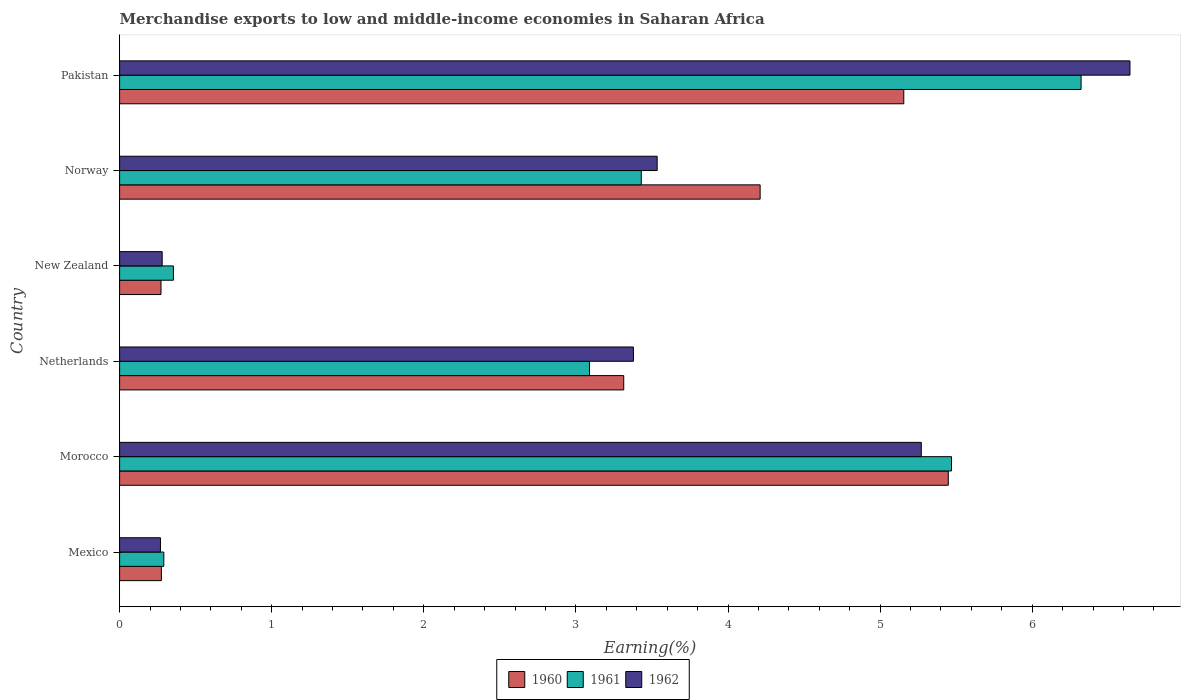How many different coloured bars are there?
Offer a terse response. 3. How many groups of bars are there?
Offer a terse response. 6. Are the number of bars per tick equal to the number of legend labels?
Ensure brevity in your answer.  Yes. Are the number of bars on each tick of the Y-axis equal?
Make the answer very short. Yes. How many bars are there on the 6th tick from the top?
Offer a very short reply. 3. What is the label of the 5th group of bars from the top?
Ensure brevity in your answer.  Morocco. What is the percentage of amount earned from merchandise exports in 1961 in Norway?
Provide a succinct answer. 3.43. Across all countries, what is the maximum percentage of amount earned from merchandise exports in 1962?
Provide a short and direct response. 6.64. Across all countries, what is the minimum percentage of amount earned from merchandise exports in 1961?
Your answer should be very brief. 0.29. In which country was the percentage of amount earned from merchandise exports in 1960 maximum?
Your response must be concise. Morocco. In which country was the percentage of amount earned from merchandise exports in 1961 minimum?
Keep it short and to the point. Mexico. What is the total percentage of amount earned from merchandise exports in 1962 in the graph?
Offer a terse response. 19.37. What is the difference between the percentage of amount earned from merchandise exports in 1962 in Mexico and that in Netherlands?
Your answer should be compact. -3.11. What is the difference between the percentage of amount earned from merchandise exports in 1961 in Morocco and the percentage of amount earned from merchandise exports in 1960 in Mexico?
Keep it short and to the point. 5.19. What is the average percentage of amount earned from merchandise exports in 1960 per country?
Give a very brief answer. 3.11. What is the difference between the percentage of amount earned from merchandise exports in 1962 and percentage of amount earned from merchandise exports in 1961 in Norway?
Offer a very short reply. 0.1. What is the ratio of the percentage of amount earned from merchandise exports in 1961 in Netherlands to that in Pakistan?
Your answer should be compact. 0.49. What is the difference between the highest and the second highest percentage of amount earned from merchandise exports in 1961?
Your answer should be compact. 0.85. What is the difference between the highest and the lowest percentage of amount earned from merchandise exports in 1962?
Keep it short and to the point. 6.37. In how many countries, is the percentage of amount earned from merchandise exports in 1962 greater than the average percentage of amount earned from merchandise exports in 1962 taken over all countries?
Give a very brief answer. 4. Is the sum of the percentage of amount earned from merchandise exports in 1962 in Morocco and New Zealand greater than the maximum percentage of amount earned from merchandise exports in 1960 across all countries?
Your answer should be compact. Yes. What does the 2nd bar from the bottom in Netherlands represents?
Your response must be concise. 1961. Is it the case that in every country, the sum of the percentage of amount earned from merchandise exports in 1961 and percentage of amount earned from merchandise exports in 1960 is greater than the percentage of amount earned from merchandise exports in 1962?
Provide a succinct answer. Yes. How many bars are there?
Offer a very short reply. 18. Are the values on the major ticks of X-axis written in scientific E-notation?
Ensure brevity in your answer.  No. Does the graph contain grids?
Provide a succinct answer. No. How are the legend labels stacked?
Your answer should be very brief. Horizontal. What is the title of the graph?
Provide a short and direct response. Merchandise exports to low and middle-income economies in Saharan Africa. What is the label or title of the X-axis?
Make the answer very short. Earning(%). What is the Earning(%) of 1960 in Mexico?
Provide a short and direct response. 0.27. What is the Earning(%) of 1961 in Mexico?
Keep it short and to the point. 0.29. What is the Earning(%) in 1962 in Mexico?
Ensure brevity in your answer.  0.27. What is the Earning(%) of 1960 in Morocco?
Make the answer very short. 5.45. What is the Earning(%) of 1961 in Morocco?
Provide a succinct answer. 5.47. What is the Earning(%) of 1962 in Morocco?
Make the answer very short. 5.27. What is the Earning(%) of 1960 in Netherlands?
Make the answer very short. 3.31. What is the Earning(%) of 1961 in Netherlands?
Provide a short and direct response. 3.09. What is the Earning(%) in 1962 in Netherlands?
Ensure brevity in your answer.  3.38. What is the Earning(%) of 1960 in New Zealand?
Provide a succinct answer. 0.27. What is the Earning(%) in 1961 in New Zealand?
Provide a short and direct response. 0.35. What is the Earning(%) in 1962 in New Zealand?
Your answer should be very brief. 0.28. What is the Earning(%) of 1960 in Norway?
Give a very brief answer. 4.21. What is the Earning(%) of 1961 in Norway?
Provide a succinct answer. 3.43. What is the Earning(%) of 1962 in Norway?
Your answer should be compact. 3.53. What is the Earning(%) of 1960 in Pakistan?
Offer a very short reply. 5.16. What is the Earning(%) of 1961 in Pakistan?
Offer a very short reply. 6.32. What is the Earning(%) in 1962 in Pakistan?
Offer a terse response. 6.64. Across all countries, what is the maximum Earning(%) of 1960?
Ensure brevity in your answer.  5.45. Across all countries, what is the maximum Earning(%) in 1961?
Offer a terse response. 6.32. Across all countries, what is the maximum Earning(%) of 1962?
Give a very brief answer. 6.64. Across all countries, what is the minimum Earning(%) in 1960?
Make the answer very short. 0.27. Across all countries, what is the minimum Earning(%) in 1961?
Your response must be concise. 0.29. Across all countries, what is the minimum Earning(%) of 1962?
Offer a very short reply. 0.27. What is the total Earning(%) of 1960 in the graph?
Provide a short and direct response. 18.68. What is the total Earning(%) of 1961 in the graph?
Provide a short and direct response. 18.95. What is the total Earning(%) in 1962 in the graph?
Your response must be concise. 19.37. What is the difference between the Earning(%) of 1960 in Mexico and that in Morocco?
Make the answer very short. -5.17. What is the difference between the Earning(%) in 1961 in Mexico and that in Morocco?
Your answer should be compact. -5.18. What is the difference between the Earning(%) of 1962 in Mexico and that in Morocco?
Offer a terse response. -5. What is the difference between the Earning(%) in 1960 in Mexico and that in Netherlands?
Your response must be concise. -3.04. What is the difference between the Earning(%) of 1961 in Mexico and that in Netherlands?
Your answer should be very brief. -2.8. What is the difference between the Earning(%) of 1962 in Mexico and that in Netherlands?
Provide a succinct answer. -3.11. What is the difference between the Earning(%) of 1960 in Mexico and that in New Zealand?
Your answer should be very brief. 0. What is the difference between the Earning(%) of 1961 in Mexico and that in New Zealand?
Provide a short and direct response. -0.06. What is the difference between the Earning(%) of 1962 in Mexico and that in New Zealand?
Your answer should be very brief. -0.01. What is the difference between the Earning(%) of 1960 in Mexico and that in Norway?
Give a very brief answer. -3.94. What is the difference between the Earning(%) in 1961 in Mexico and that in Norway?
Ensure brevity in your answer.  -3.14. What is the difference between the Earning(%) of 1962 in Mexico and that in Norway?
Offer a terse response. -3.27. What is the difference between the Earning(%) in 1960 in Mexico and that in Pakistan?
Provide a succinct answer. -4.88. What is the difference between the Earning(%) in 1961 in Mexico and that in Pakistan?
Your answer should be very brief. -6.03. What is the difference between the Earning(%) in 1962 in Mexico and that in Pakistan?
Provide a succinct answer. -6.37. What is the difference between the Earning(%) in 1960 in Morocco and that in Netherlands?
Your answer should be very brief. 2.13. What is the difference between the Earning(%) in 1961 in Morocco and that in Netherlands?
Provide a succinct answer. 2.38. What is the difference between the Earning(%) in 1962 in Morocco and that in Netherlands?
Your answer should be very brief. 1.89. What is the difference between the Earning(%) in 1960 in Morocco and that in New Zealand?
Ensure brevity in your answer.  5.18. What is the difference between the Earning(%) of 1961 in Morocco and that in New Zealand?
Provide a succinct answer. 5.12. What is the difference between the Earning(%) in 1962 in Morocco and that in New Zealand?
Offer a very short reply. 4.99. What is the difference between the Earning(%) in 1960 in Morocco and that in Norway?
Your answer should be very brief. 1.24. What is the difference between the Earning(%) of 1961 in Morocco and that in Norway?
Ensure brevity in your answer.  2.04. What is the difference between the Earning(%) of 1962 in Morocco and that in Norway?
Your answer should be very brief. 1.74. What is the difference between the Earning(%) of 1960 in Morocco and that in Pakistan?
Ensure brevity in your answer.  0.29. What is the difference between the Earning(%) in 1961 in Morocco and that in Pakistan?
Provide a short and direct response. -0.85. What is the difference between the Earning(%) of 1962 in Morocco and that in Pakistan?
Offer a terse response. -1.37. What is the difference between the Earning(%) in 1960 in Netherlands and that in New Zealand?
Provide a short and direct response. 3.04. What is the difference between the Earning(%) of 1961 in Netherlands and that in New Zealand?
Keep it short and to the point. 2.74. What is the difference between the Earning(%) in 1962 in Netherlands and that in New Zealand?
Keep it short and to the point. 3.1. What is the difference between the Earning(%) in 1960 in Netherlands and that in Norway?
Offer a very short reply. -0.9. What is the difference between the Earning(%) of 1961 in Netherlands and that in Norway?
Keep it short and to the point. -0.34. What is the difference between the Earning(%) in 1962 in Netherlands and that in Norway?
Your answer should be compact. -0.16. What is the difference between the Earning(%) of 1960 in Netherlands and that in Pakistan?
Keep it short and to the point. -1.84. What is the difference between the Earning(%) of 1961 in Netherlands and that in Pakistan?
Give a very brief answer. -3.23. What is the difference between the Earning(%) of 1962 in Netherlands and that in Pakistan?
Provide a short and direct response. -3.26. What is the difference between the Earning(%) in 1960 in New Zealand and that in Norway?
Give a very brief answer. -3.94. What is the difference between the Earning(%) in 1961 in New Zealand and that in Norway?
Provide a succinct answer. -3.08. What is the difference between the Earning(%) of 1962 in New Zealand and that in Norway?
Your response must be concise. -3.25. What is the difference between the Earning(%) in 1960 in New Zealand and that in Pakistan?
Your answer should be compact. -4.88. What is the difference between the Earning(%) in 1961 in New Zealand and that in Pakistan?
Your answer should be very brief. -5.97. What is the difference between the Earning(%) in 1962 in New Zealand and that in Pakistan?
Your response must be concise. -6.36. What is the difference between the Earning(%) in 1960 in Norway and that in Pakistan?
Offer a terse response. -0.94. What is the difference between the Earning(%) in 1961 in Norway and that in Pakistan?
Ensure brevity in your answer.  -2.89. What is the difference between the Earning(%) in 1962 in Norway and that in Pakistan?
Keep it short and to the point. -3.11. What is the difference between the Earning(%) of 1960 in Mexico and the Earning(%) of 1961 in Morocco?
Keep it short and to the point. -5.19. What is the difference between the Earning(%) in 1960 in Mexico and the Earning(%) in 1962 in Morocco?
Provide a short and direct response. -5. What is the difference between the Earning(%) of 1961 in Mexico and the Earning(%) of 1962 in Morocco?
Your response must be concise. -4.98. What is the difference between the Earning(%) in 1960 in Mexico and the Earning(%) in 1961 in Netherlands?
Provide a short and direct response. -2.81. What is the difference between the Earning(%) of 1960 in Mexico and the Earning(%) of 1962 in Netherlands?
Offer a very short reply. -3.1. What is the difference between the Earning(%) of 1961 in Mexico and the Earning(%) of 1962 in Netherlands?
Offer a very short reply. -3.09. What is the difference between the Earning(%) in 1960 in Mexico and the Earning(%) in 1961 in New Zealand?
Your answer should be compact. -0.08. What is the difference between the Earning(%) of 1960 in Mexico and the Earning(%) of 1962 in New Zealand?
Ensure brevity in your answer.  -0.01. What is the difference between the Earning(%) of 1961 in Mexico and the Earning(%) of 1962 in New Zealand?
Offer a very short reply. 0.01. What is the difference between the Earning(%) of 1960 in Mexico and the Earning(%) of 1961 in Norway?
Provide a short and direct response. -3.15. What is the difference between the Earning(%) of 1960 in Mexico and the Earning(%) of 1962 in Norway?
Provide a succinct answer. -3.26. What is the difference between the Earning(%) in 1961 in Mexico and the Earning(%) in 1962 in Norway?
Offer a very short reply. -3.24. What is the difference between the Earning(%) of 1960 in Mexico and the Earning(%) of 1961 in Pakistan?
Give a very brief answer. -6.05. What is the difference between the Earning(%) in 1960 in Mexico and the Earning(%) in 1962 in Pakistan?
Provide a short and direct response. -6.37. What is the difference between the Earning(%) of 1961 in Mexico and the Earning(%) of 1962 in Pakistan?
Your response must be concise. -6.35. What is the difference between the Earning(%) in 1960 in Morocco and the Earning(%) in 1961 in Netherlands?
Your answer should be very brief. 2.36. What is the difference between the Earning(%) in 1960 in Morocco and the Earning(%) in 1962 in Netherlands?
Your answer should be very brief. 2.07. What is the difference between the Earning(%) of 1961 in Morocco and the Earning(%) of 1962 in Netherlands?
Offer a very short reply. 2.09. What is the difference between the Earning(%) in 1960 in Morocco and the Earning(%) in 1961 in New Zealand?
Ensure brevity in your answer.  5.09. What is the difference between the Earning(%) in 1960 in Morocco and the Earning(%) in 1962 in New Zealand?
Offer a very short reply. 5.17. What is the difference between the Earning(%) in 1961 in Morocco and the Earning(%) in 1962 in New Zealand?
Keep it short and to the point. 5.19. What is the difference between the Earning(%) of 1960 in Morocco and the Earning(%) of 1961 in Norway?
Give a very brief answer. 2.02. What is the difference between the Earning(%) of 1960 in Morocco and the Earning(%) of 1962 in Norway?
Give a very brief answer. 1.91. What is the difference between the Earning(%) in 1961 in Morocco and the Earning(%) in 1962 in Norway?
Your answer should be very brief. 1.94. What is the difference between the Earning(%) in 1960 in Morocco and the Earning(%) in 1961 in Pakistan?
Your response must be concise. -0.87. What is the difference between the Earning(%) in 1960 in Morocco and the Earning(%) in 1962 in Pakistan?
Keep it short and to the point. -1.19. What is the difference between the Earning(%) of 1961 in Morocco and the Earning(%) of 1962 in Pakistan?
Ensure brevity in your answer.  -1.17. What is the difference between the Earning(%) of 1960 in Netherlands and the Earning(%) of 1961 in New Zealand?
Provide a succinct answer. 2.96. What is the difference between the Earning(%) in 1960 in Netherlands and the Earning(%) in 1962 in New Zealand?
Your answer should be very brief. 3.03. What is the difference between the Earning(%) of 1961 in Netherlands and the Earning(%) of 1962 in New Zealand?
Provide a succinct answer. 2.81. What is the difference between the Earning(%) of 1960 in Netherlands and the Earning(%) of 1961 in Norway?
Provide a short and direct response. -0.12. What is the difference between the Earning(%) of 1960 in Netherlands and the Earning(%) of 1962 in Norway?
Provide a succinct answer. -0.22. What is the difference between the Earning(%) in 1961 in Netherlands and the Earning(%) in 1962 in Norway?
Provide a succinct answer. -0.44. What is the difference between the Earning(%) in 1960 in Netherlands and the Earning(%) in 1961 in Pakistan?
Your answer should be compact. -3.01. What is the difference between the Earning(%) in 1960 in Netherlands and the Earning(%) in 1962 in Pakistan?
Give a very brief answer. -3.33. What is the difference between the Earning(%) of 1961 in Netherlands and the Earning(%) of 1962 in Pakistan?
Provide a short and direct response. -3.55. What is the difference between the Earning(%) of 1960 in New Zealand and the Earning(%) of 1961 in Norway?
Ensure brevity in your answer.  -3.16. What is the difference between the Earning(%) in 1960 in New Zealand and the Earning(%) in 1962 in Norway?
Offer a terse response. -3.26. What is the difference between the Earning(%) of 1961 in New Zealand and the Earning(%) of 1962 in Norway?
Offer a very short reply. -3.18. What is the difference between the Earning(%) of 1960 in New Zealand and the Earning(%) of 1961 in Pakistan?
Provide a succinct answer. -6.05. What is the difference between the Earning(%) of 1960 in New Zealand and the Earning(%) of 1962 in Pakistan?
Your answer should be compact. -6.37. What is the difference between the Earning(%) in 1961 in New Zealand and the Earning(%) in 1962 in Pakistan?
Your answer should be very brief. -6.29. What is the difference between the Earning(%) in 1960 in Norway and the Earning(%) in 1961 in Pakistan?
Your response must be concise. -2.11. What is the difference between the Earning(%) in 1960 in Norway and the Earning(%) in 1962 in Pakistan?
Your answer should be very brief. -2.43. What is the difference between the Earning(%) of 1961 in Norway and the Earning(%) of 1962 in Pakistan?
Keep it short and to the point. -3.21. What is the average Earning(%) of 1960 per country?
Keep it short and to the point. 3.11. What is the average Earning(%) in 1961 per country?
Offer a terse response. 3.16. What is the average Earning(%) in 1962 per country?
Provide a short and direct response. 3.23. What is the difference between the Earning(%) of 1960 and Earning(%) of 1961 in Mexico?
Provide a short and direct response. -0.02. What is the difference between the Earning(%) of 1960 and Earning(%) of 1962 in Mexico?
Ensure brevity in your answer.  0.01. What is the difference between the Earning(%) in 1961 and Earning(%) in 1962 in Mexico?
Your answer should be very brief. 0.02. What is the difference between the Earning(%) in 1960 and Earning(%) in 1961 in Morocco?
Your response must be concise. -0.02. What is the difference between the Earning(%) in 1960 and Earning(%) in 1962 in Morocco?
Offer a very short reply. 0.18. What is the difference between the Earning(%) of 1961 and Earning(%) of 1962 in Morocco?
Offer a very short reply. 0.2. What is the difference between the Earning(%) in 1960 and Earning(%) in 1961 in Netherlands?
Your response must be concise. 0.23. What is the difference between the Earning(%) in 1960 and Earning(%) in 1962 in Netherlands?
Your answer should be compact. -0.06. What is the difference between the Earning(%) of 1961 and Earning(%) of 1962 in Netherlands?
Offer a very short reply. -0.29. What is the difference between the Earning(%) of 1960 and Earning(%) of 1961 in New Zealand?
Provide a short and direct response. -0.08. What is the difference between the Earning(%) of 1960 and Earning(%) of 1962 in New Zealand?
Ensure brevity in your answer.  -0.01. What is the difference between the Earning(%) of 1961 and Earning(%) of 1962 in New Zealand?
Keep it short and to the point. 0.07. What is the difference between the Earning(%) of 1960 and Earning(%) of 1961 in Norway?
Ensure brevity in your answer.  0.78. What is the difference between the Earning(%) in 1960 and Earning(%) in 1962 in Norway?
Give a very brief answer. 0.68. What is the difference between the Earning(%) in 1961 and Earning(%) in 1962 in Norway?
Provide a short and direct response. -0.1. What is the difference between the Earning(%) of 1960 and Earning(%) of 1961 in Pakistan?
Your answer should be compact. -1.17. What is the difference between the Earning(%) in 1960 and Earning(%) in 1962 in Pakistan?
Provide a succinct answer. -1.49. What is the difference between the Earning(%) of 1961 and Earning(%) of 1962 in Pakistan?
Give a very brief answer. -0.32. What is the ratio of the Earning(%) in 1960 in Mexico to that in Morocco?
Make the answer very short. 0.05. What is the ratio of the Earning(%) in 1961 in Mexico to that in Morocco?
Give a very brief answer. 0.05. What is the ratio of the Earning(%) of 1962 in Mexico to that in Morocco?
Provide a short and direct response. 0.05. What is the ratio of the Earning(%) of 1960 in Mexico to that in Netherlands?
Provide a short and direct response. 0.08. What is the ratio of the Earning(%) of 1961 in Mexico to that in Netherlands?
Your answer should be compact. 0.09. What is the ratio of the Earning(%) in 1962 in Mexico to that in Netherlands?
Provide a succinct answer. 0.08. What is the ratio of the Earning(%) in 1960 in Mexico to that in New Zealand?
Provide a succinct answer. 1.01. What is the ratio of the Earning(%) of 1961 in Mexico to that in New Zealand?
Your answer should be compact. 0.82. What is the ratio of the Earning(%) of 1962 in Mexico to that in New Zealand?
Your response must be concise. 0.96. What is the ratio of the Earning(%) of 1960 in Mexico to that in Norway?
Provide a succinct answer. 0.07. What is the ratio of the Earning(%) of 1961 in Mexico to that in Norway?
Offer a very short reply. 0.08. What is the ratio of the Earning(%) in 1962 in Mexico to that in Norway?
Your answer should be compact. 0.08. What is the ratio of the Earning(%) of 1960 in Mexico to that in Pakistan?
Provide a short and direct response. 0.05. What is the ratio of the Earning(%) of 1961 in Mexico to that in Pakistan?
Offer a very short reply. 0.05. What is the ratio of the Earning(%) of 1962 in Mexico to that in Pakistan?
Give a very brief answer. 0.04. What is the ratio of the Earning(%) of 1960 in Morocco to that in Netherlands?
Your response must be concise. 1.64. What is the ratio of the Earning(%) in 1961 in Morocco to that in Netherlands?
Your response must be concise. 1.77. What is the ratio of the Earning(%) in 1962 in Morocco to that in Netherlands?
Keep it short and to the point. 1.56. What is the ratio of the Earning(%) in 1960 in Morocco to that in New Zealand?
Offer a very short reply. 20.01. What is the ratio of the Earning(%) in 1961 in Morocco to that in New Zealand?
Ensure brevity in your answer.  15.46. What is the ratio of the Earning(%) of 1962 in Morocco to that in New Zealand?
Keep it short and to the point. 18.83. What is the ratio of the Earning(%) in 1960 in Morocco to that in Norway?
Your answer should be compact. 1.29. What is the ratio of the Earning(%) of 1961 in Morocco to that in Norway?
Your answer should be compact. 1.59. What is the ratio of the Earning(%) of 1962 in Morocco to that in Norway?
Your answer should be very brief. 1.49. What is the ratio of the Earning(%) of 1960 in Morocco to that in Pakistan?
Keep it short and to the point. 1.06. What is the ratio of the Earning(%) of 1961 in Morocco to that in Pakistan?
Your answer should be compact. 0.87. What is the ratio of the Earning(%) in 1962 in Morocco to that in Pakistan?
Offer a very short reply. 0.79. What is the ratio of the Earning(%) in 1960 in Netherlands to that in New Zealand?
Offer a terse response. 12.18. What is the ratio of the Earning(%) in 1961 in Netherlands to that in New Zealand?
Give a very brief answer. 8.73. What is the ratio of the Earning(%) of 1962 in Netherlands to that in New Zealand?
Make the answer very short. 12.07. What is the ratio of the Earning(%) of 1960 in Netherlands to that in Norway?
Offer a terse response. 0.79. What is the ratio of the Earning(%) of 1961 in Netherlands to that in Norway?
Your answer should be very brief. 0.9. What is the ratio of the Earning(%) of 1962 in Netherlands to that in Norway?
Your answer should be compact. 0.96. What is the ratio of the Earning(%) in 1960 in Netherlands to that in Pakistan?
Your response must be concise. 0.64. What is the ratio of the Earning(%) of 1961 in Netherlands to that in Pakistan?
Provide a succinct answer. 0.49. What is the ratio of the Earning(%) of 1962 in Netherlands to that in Pakistan?
Make the answer very short. 0.51. What is the ratio of the Earning(%) of 1960 in New Zealand to that in Norway?
Offer a very short reply. 0.06. What is the ratio of the Earning(%) in 1961 in New Zealand to that in Norway?
Keep it short and to the point. 0.1. What is the ratio of the Earning(%) of 1962 in New Zealand to that in Norway?
Your response must be concise. 0.08. What is the ratio of the Earning(%) of 1960 in New Zealand to that in Pakistan?
Give a very brief answer. 0.05. What is the ratio of the Earning(%) in 1961 in New Zealand to that in Pakistan?
Provide a short and direct response. 0.06. What is the ratio of the Earning(%) of 1962 in New Zealand to that in Pakistan?
Your response must be concise. 0.04. What is the ratio of the Earning(%) of 1960 in Norway to that in Pakistan?
Keep it short and to the point. 0.82. What is the ratio of the Earning(%) in 1961 in Norway to that in Pakistan?
Keep it short and to the point. 0.54. What is the ratio of the Earning(%) in 1962 in Norway to that in Pakistan?
Offer a very short reply. 0.53. What is the difference between the highest and the second highest Earning(%) of 1960?
Your response must be concise. 0.29. What is the difference between the highest and the second highest Earning(%) in 1961?
Your response must be concise. 0.85. What is the difference between the highest and the second highest Earning(%) in 1962?
Provide a succinct answer. 1.37. What is the difference between the highest and the lowest Earning(%) of 1960?
Ensure brevity in your answer.  5.18. What is the difference between the highest and the lowest Earning(%) of 1961?
Ensure brevity in your answer.  6.03. What is the difference between the highest and the lowest Earning(%) of 1962?
Offer a terse response. 6.37. 